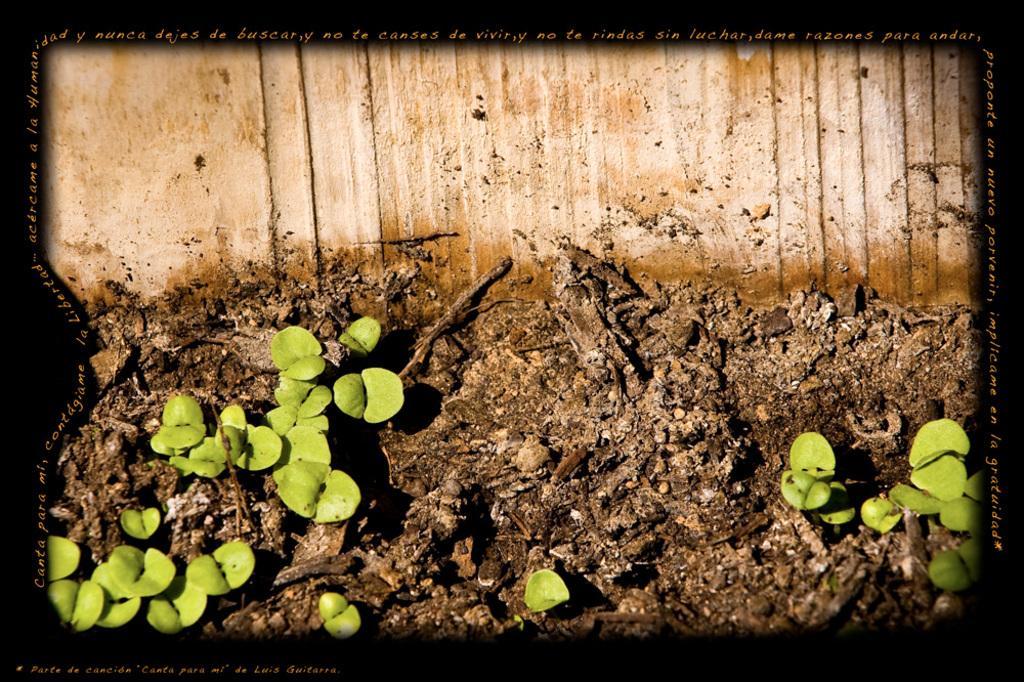How would you summarize this image in a sentence or two? It is an edited picture. In this image, we can see few plants and wall. The borders of the image, we can see black color and some text. 